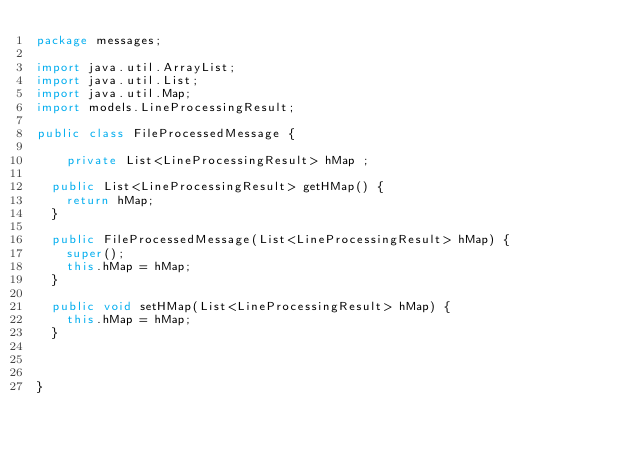Convert code to text. <code><loc_0><loc_0><loc_500><loc_500><_Java_>package messages;

import java.util.ArrayList;
import java.util.List;
import java.util.Map;
import models.LineProcessingResult;

public class FileProcessedMessage {

    private List<LineProcessingResult> hMap ;

	public List<LineProcessingResult> getHMap() {
		return hMap;
	}

	public FileProcessedMessage(List<LineProcessingResult> hMap) {
		super();
		this.hMap = hMap;
	}

	public void setHMap(List<LineProcessingResult> hMap) {
		this.hMap = hMap;
	}

    

}
</code> 